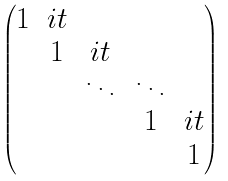<formula> <loc_0><loc_0><loc_500><loc_500>\begin{pmatrix} 1 & i t & & & \\ & 1 & i t & & \\ & & \ddots & \ddots & \\ & & & 1 & i t \\ & & & & 1 \end{pmatrix}</formula> 